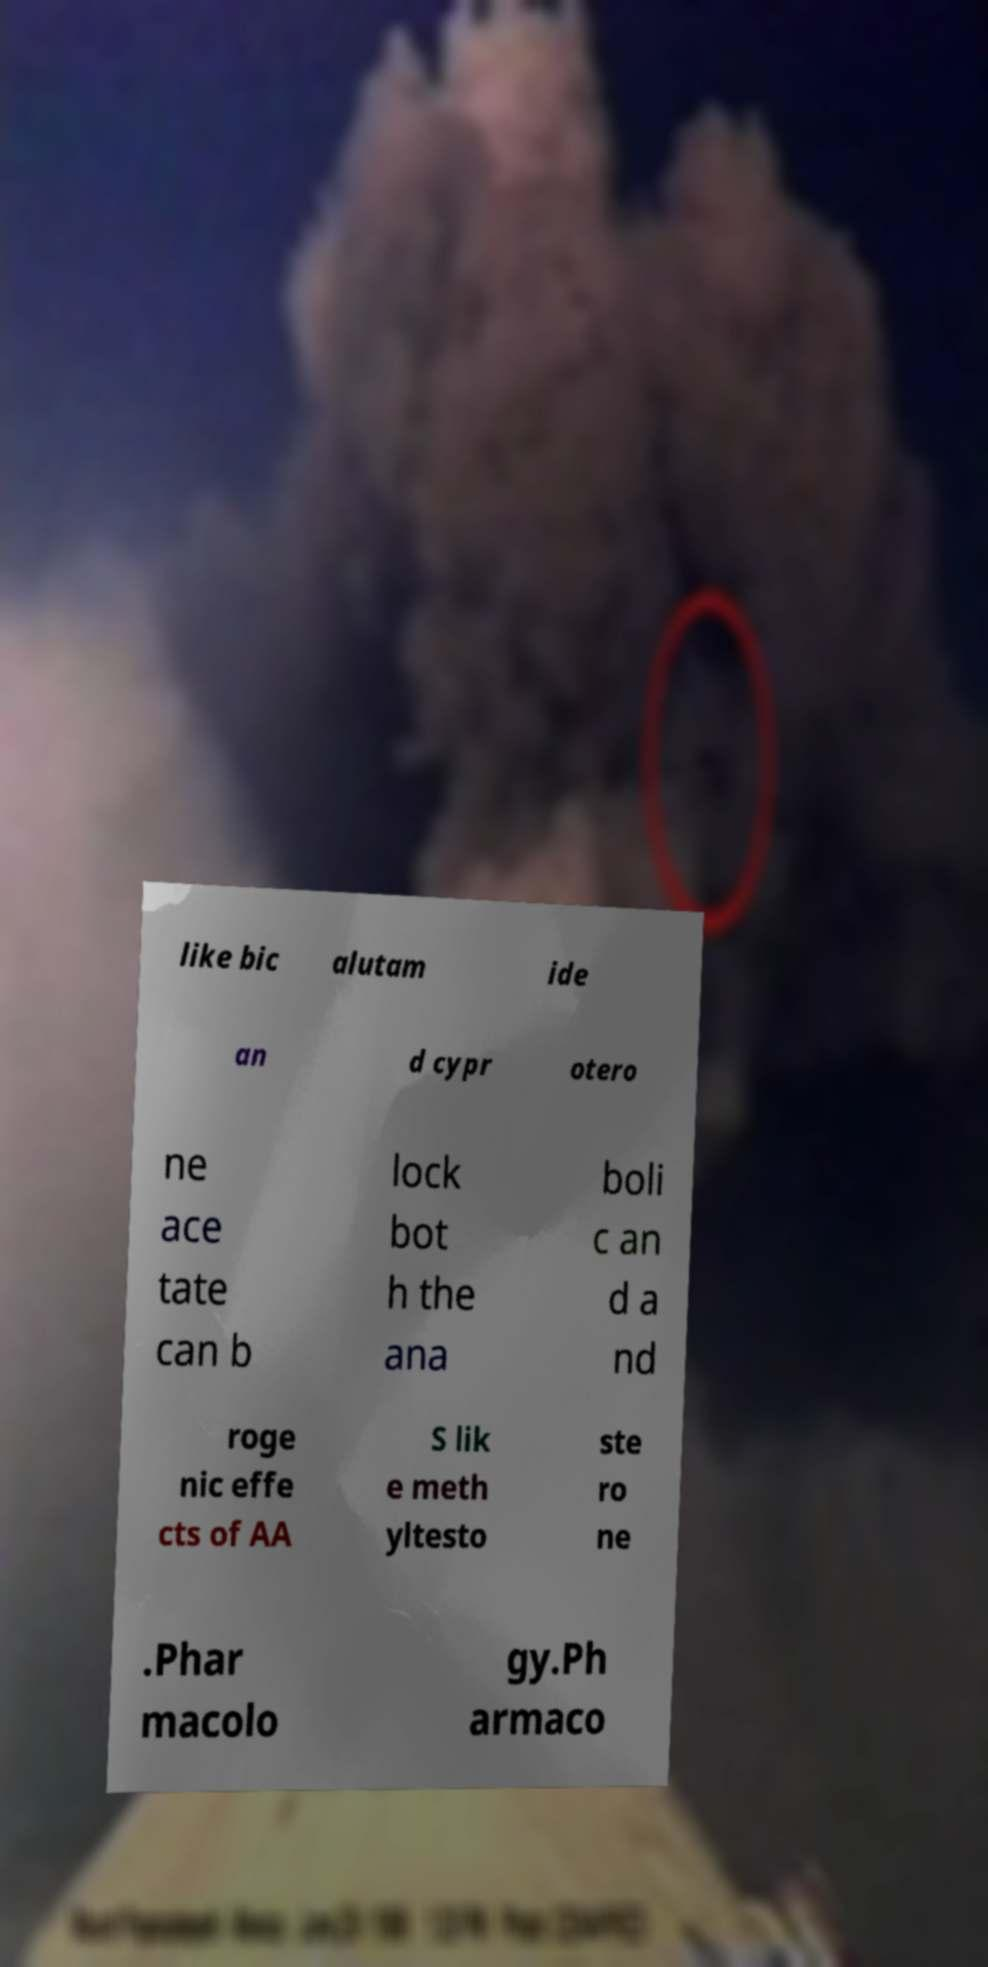Please identify and transcribe the text found in this image. like bic alutam ide an d cypr otero ne ace tate can b lock bot h the ana boli c an d a nd roge nic effe cts of AA S lik e meth yltesto ste ro ne .Phar macolo gy.Ph armaco 